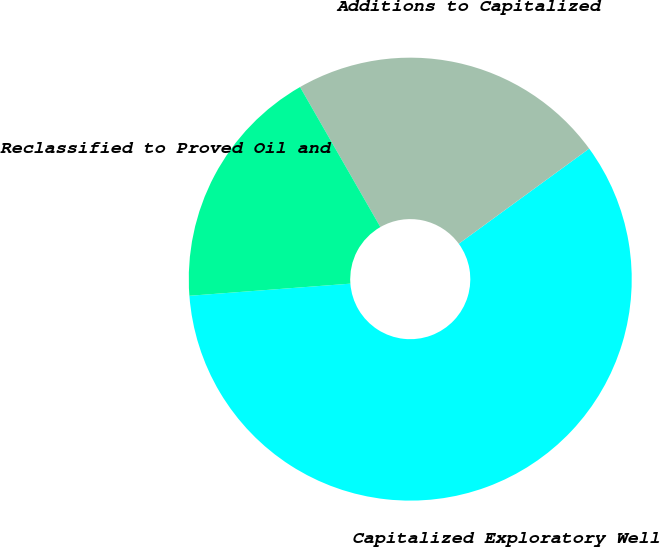<chart> <loc_0><loc_0><loc_500><loc_500><pie_chart><fcel>Capitalized Exploratory Well<fcel>Additions to Capitalized<fcel>Reclassified to Proved Oil and<nl><fcel>58.84%<fcel>23.26%<fcel>17.91%<nl></chart> 